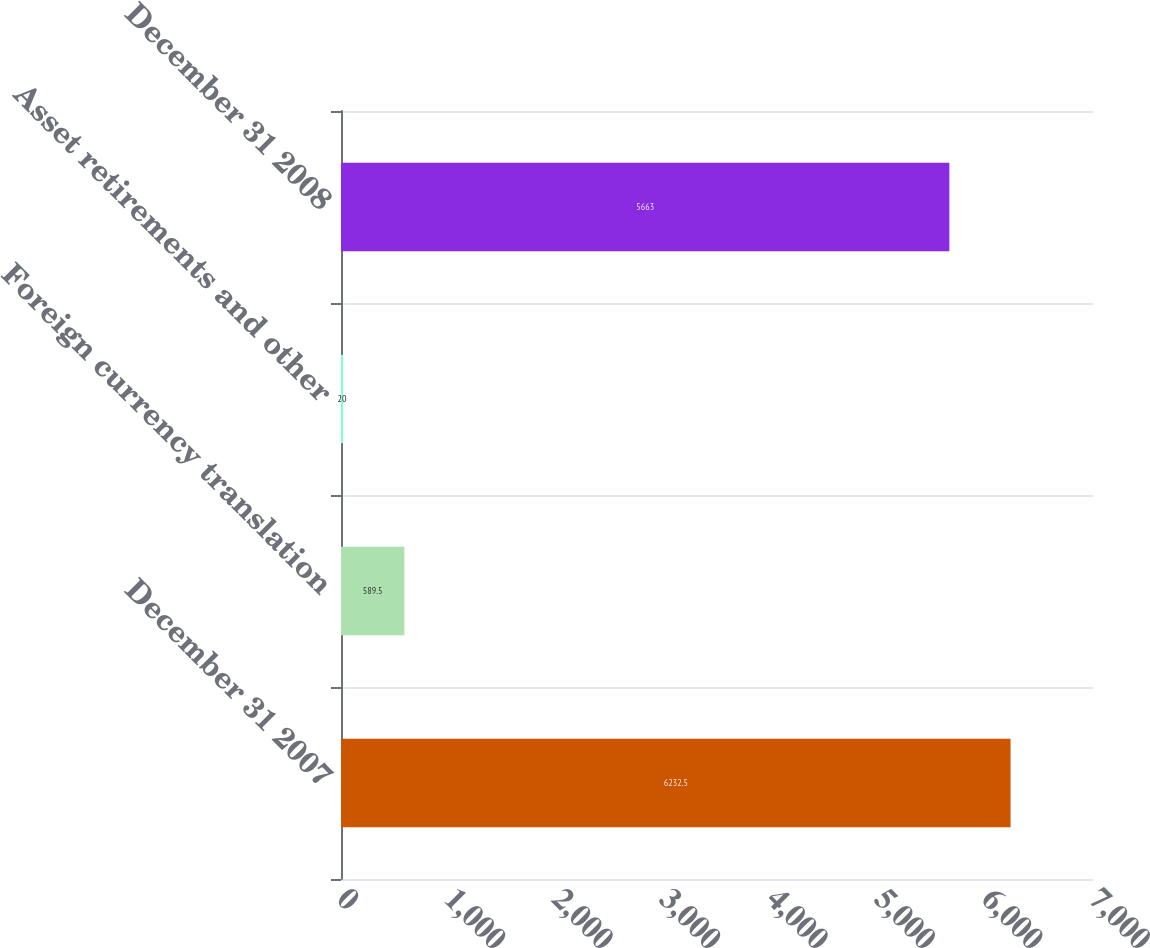Convert chart. <chart><loc_0><loc_0><loc_500><loc_500><bar_chart><fcel>December 31 2007<fcel>Foreign currency translation<fcel>Asset retirements and other<fcel>December 31 2008<nl><fcel>6232.5<fcel>589.5<fcel>20<fcel>5663<nl></chart> 